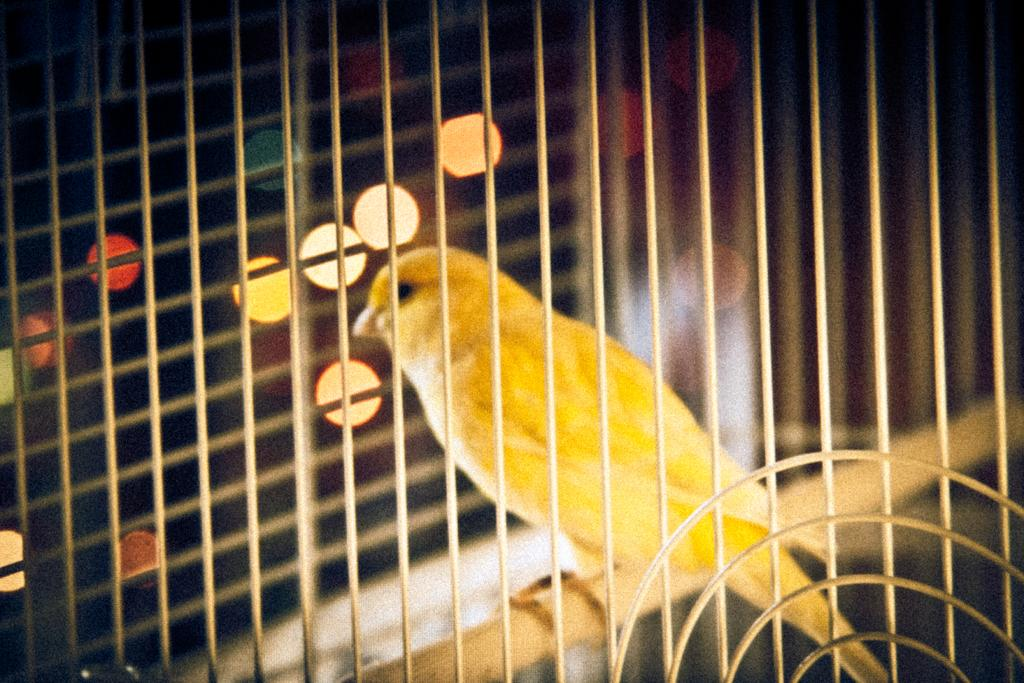What type of animal is present in the image? There is a bird in the image. Where is the bird sitting? The bird is sitting on a wooden object. What is in front of the bird? There is a mesh in front of the bird. What can be seen in the image besides the bird? There are lights visible in the image. How would you describe the background of the image? The background of the image is blurred. Can you hear the snake talking to the cows in the image? There is no snake or cows present in the image, so it is not possible to hear them talking. 